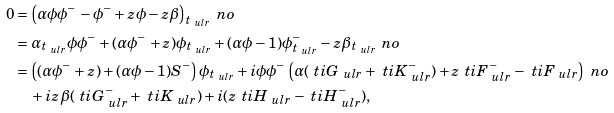<formula> <loc_0><loc_0><loc_500><loc_500>0 & = \left ( \alpha \phi \phi ^ { - } - \phi ^ { - } + z \phi - z \beta \right ) _ { t _ { \ u l r } } \ n o \\ & = \alpha _ { t _ { \ u l r } } \phi \phi ^ { - } + ( \alpha \phi ^ { - } + z ) \phi _ { t _ { \ u l r } } + ( \alpha \phi - 1 ) \phi _ { t _ { \ u l r } } ^ { - } - z \beta _ { t _ { \ u l r } } \ n o \\ & = \left ( ( \alpha \phi ^ { - } + z ) + ( \alpha \phi - 1 ) S ^ { - } \right ) \phi _ { t _ { \ u l r } } + i \phi \phi ^ { - } \left ( \alpha ( \ t i G _ { \ u l r } + \ t i K _ { \ u l r } ^ { - } ) + z \ t i F _ { \ u l r } ^ { - } - \ t i F _ { \ u l r } \right ) \ n o \\ & \quad + i z \beta ( \ t i G _ { \ u l r } ^ { - } + \ t i K _ { \ u l r } ) + i ( z \ t i H _ { \ u l r } - \ t i H _ { \ u l r } ^ { - } ) ,</formula> 